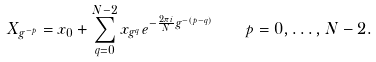Convert formula to latex. <formula><loc_0><loc_0><loc_500><loc_500>X _ { g ^ { - p } } = x _ { 0 } + \sum _ { q = 0 } ^ { N - 2 } x _ { g ^ { q } } e ^ { - { \frac { 2 \pi i } { N } } g ^ { - ( p - q ) } } \quad p = 0 , \dots , N - 2 .</formula> 